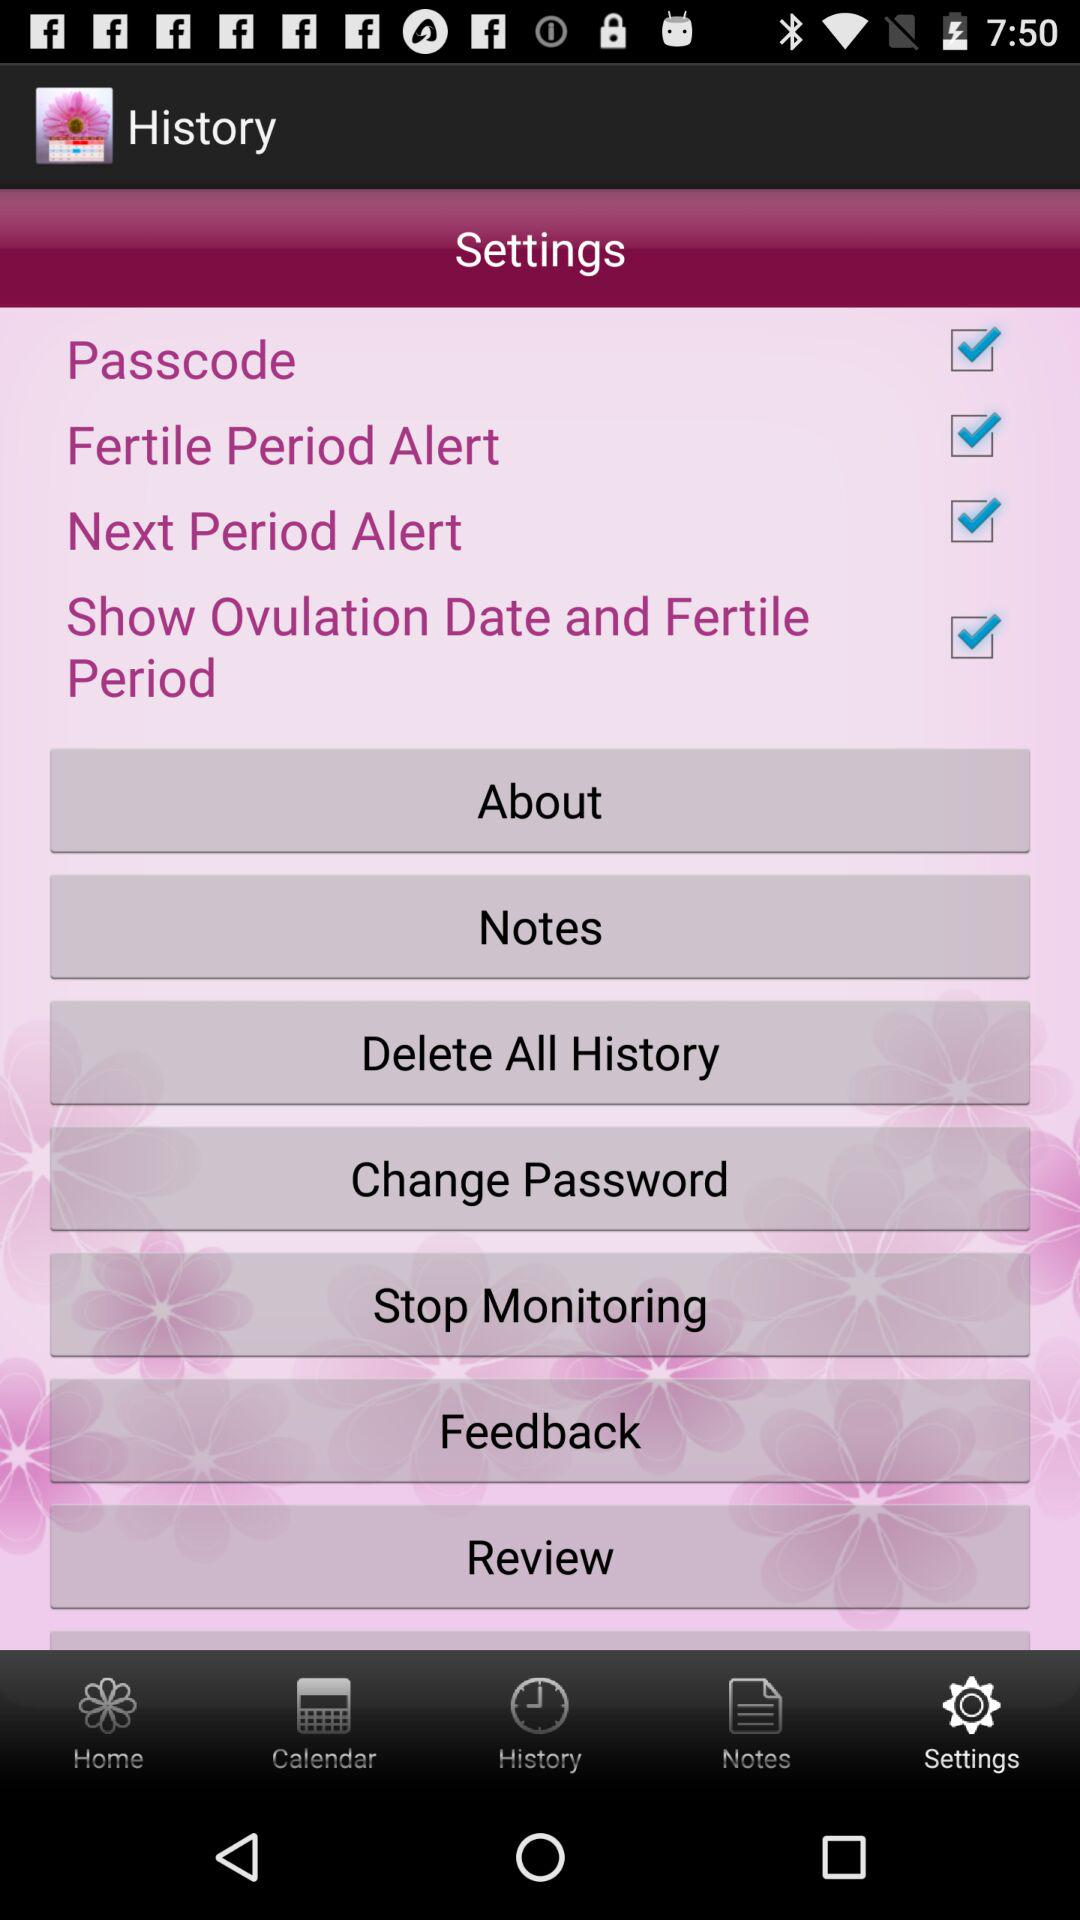What is the status of the passcode? The status is on. 